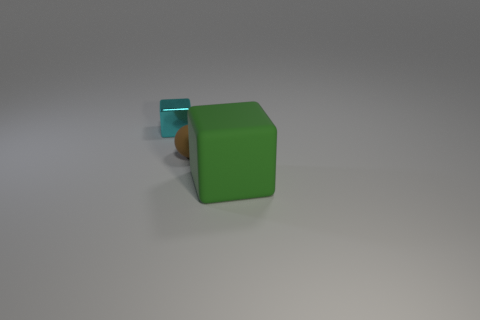Add 2 metallic cubes. How many objects exist? 5 Subtract all spheres. How many objects are left? 2 Add 2 brown spheres. How many brown spheres are left? 3 Add 2 large objects. How many large objects exist? 3 Subtract 0 blue blocks. How many objects are left? 3 Subtract all small brown rubber balls. Subtract all tiny green shiny blocks. How many objects are left? 2 